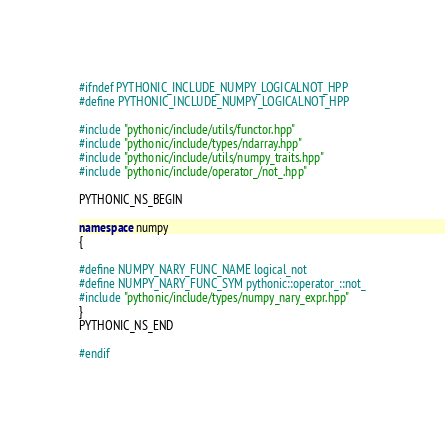Convert code to text. <code><loc_0><loc_0><loc_500><loc_500><_C++_>#ifndef PYTHONIC_INCLUDE_NUMPY_LOGICALNOT_HPP
#define PYTHONIC_INCLUDE_NUMPY_LOGICALNOT_HPP

#include "pythonic/include/utils/functor.hpp"
#include "pythonic/include/types/ndarray.hpp"
#include "pythonic/include/utils/numpy_traits.hpp"
#include "pythonic/include/operator_/not_.hpp"

PYTHONIC_NS_BEGIN

namespace numpy
{

#define NUMPY_NARY_FUNC_NAME logical_not
#define NUMPY_NARY_FUNC_SYM pythonic::operator_::not_
#include "pythonic/include/types/numpy_nary_expr.hpp"
}
PYTHONIC_NS_END

#endif
</code> 